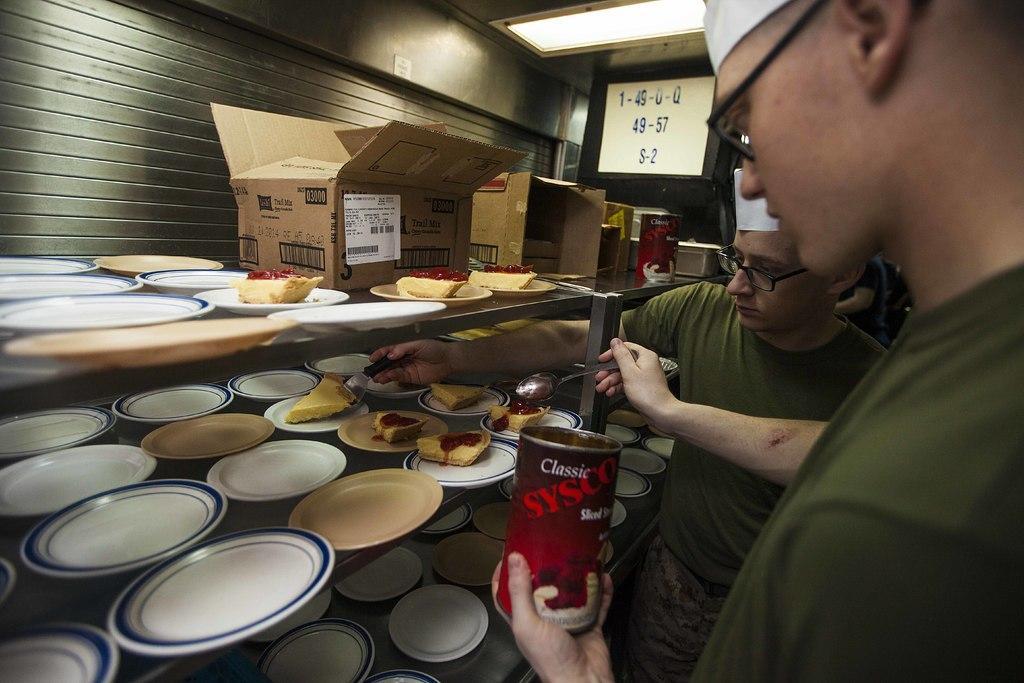Describe this image in one or two sentences. In this picture we can see men wearing spectacles and caps. We can see they are holding spoons and we can see a man on the right side is holding a container. We can see plates and we can see food in a few plates. We can see boxes, objects, boards, light and the wall. 